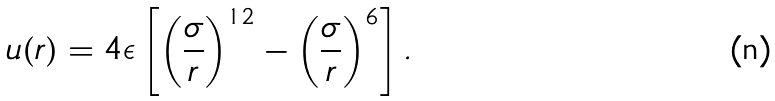Convert formula to latex. <formula><loc_0><loc_0><loc_500><loc_500>u ( r ) = 4 \epsilon \left [ \left ( \frac { \sigma } { r } \right ) ^ { 1 2 } - \left ( \frac { \sigma } { r } \right ) ^ { 6 } \right ] .</formula> 